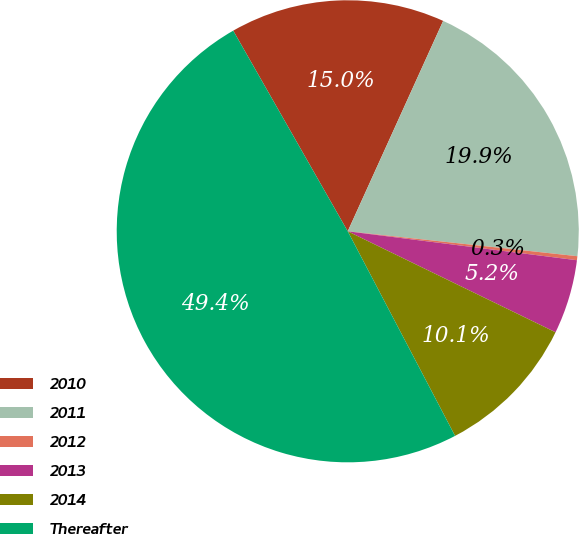Convert chart to OTSL. <chart><loc_0><loc_0><loc_500><loc_500><pie_chart><fcel>2010<fcel>2011<fcel>2012<fcel>2013<fcel>2014<fcel>Thereafter<nl><fcel>15.03%<fcel>19.94%<fcel>0.28%<fcel>5.2%<fcel>10.11%<fcel>49.43%<nl></chart> 